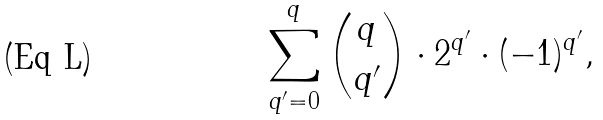Convert formula to latex. <formula><loc_0><loc_0><loc_500><loc_500>\sum _ { q ^ { \prime } = 0 } ^ { q } \binom { q } { q ^ { \prime } } \cdot 2 ^ { q ^ { \prime } } \cdot ( - 1 ) ^ { q ^ { \prime } } ,</formula> 